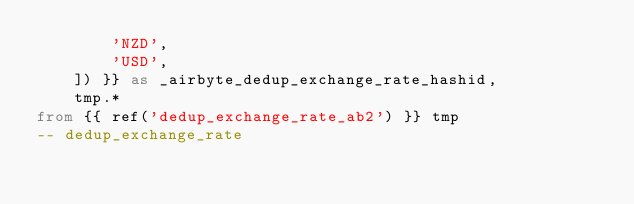Convert code to text. <code><loc_0><loc_0><loc_500><loc_500><_SQL_>        'NZD',
        'USD',
    ]) }} as _airbyte_dedup_exchange_rate_hashid,
    tmp.*
from {{ ref('dedup_exchange_rate_ab2') }} tmp
-- dedup_exchange_rate

</code> 